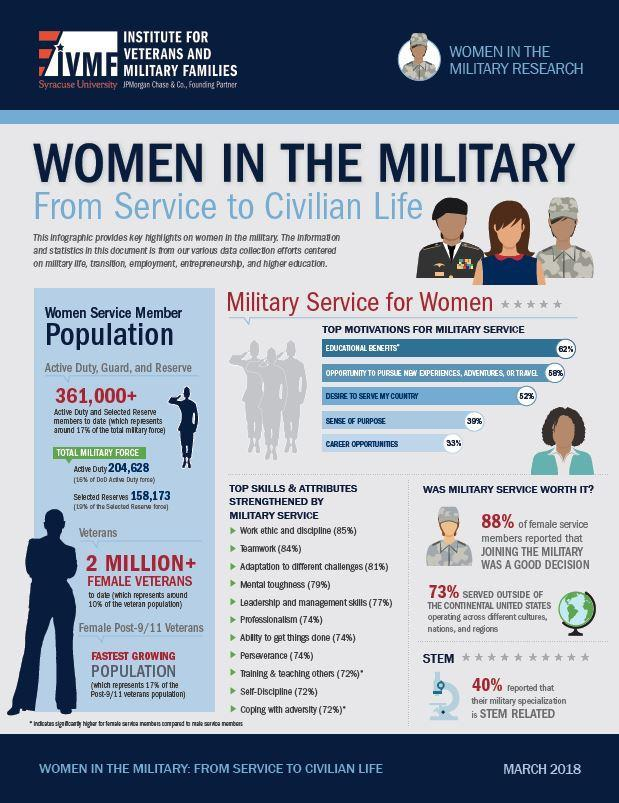What percentage of women improve their abilities in training, discipline, and facing challenges while in the army?
Answer the question with a short phrase. 72% What percentage of women in militia served in locations not within United States, 79%, 77%, or 73%? 73% 